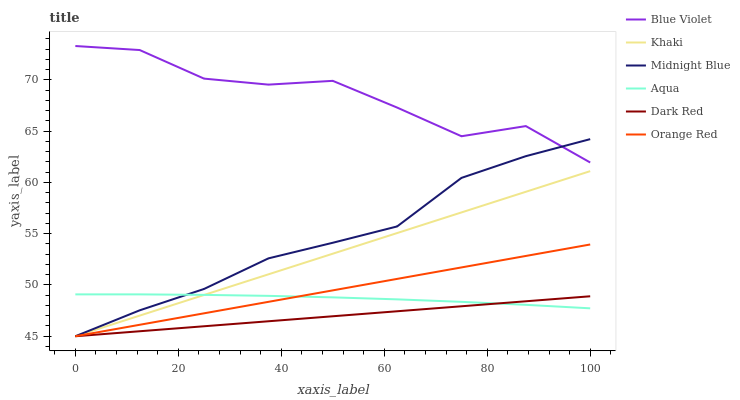Does Dark Red have the minimum area under the curve?
Answer yes or no. Yes. Does Blue Violet have the maximum area under the curve?
Answer yes or no. Yes. Does Midnight Blue have the minimum area under the curve?
Answer yes or no. No. Does Midnight Blue have the maximum area under the curve?
Answer yes or no. No. Is Dark Red the smoothest?
Answer yes or no. Yes. Is Blue Violet the roughest?
Answer yes or no. Yes. Is Midnight Blue the smoothest?
Answer yes or no. No. Is Midnight Blue the roughest?
Answer yes or no. No. Does Aqua have the lowest value?
Answer yes or no. No. Does Blue Violet have the highest value?
Answer yes or no. Yes. Does Midnight Blue have the highest value?
Answer yes or no. No. Is Aqua less than Blue Violet?
Answer yes or no. Yes. Is Blue Violet greater than Dark Red?
Answer yes or no. Yes. Does Aqua intersect Blue Violet?
Answer yes or no. No. 